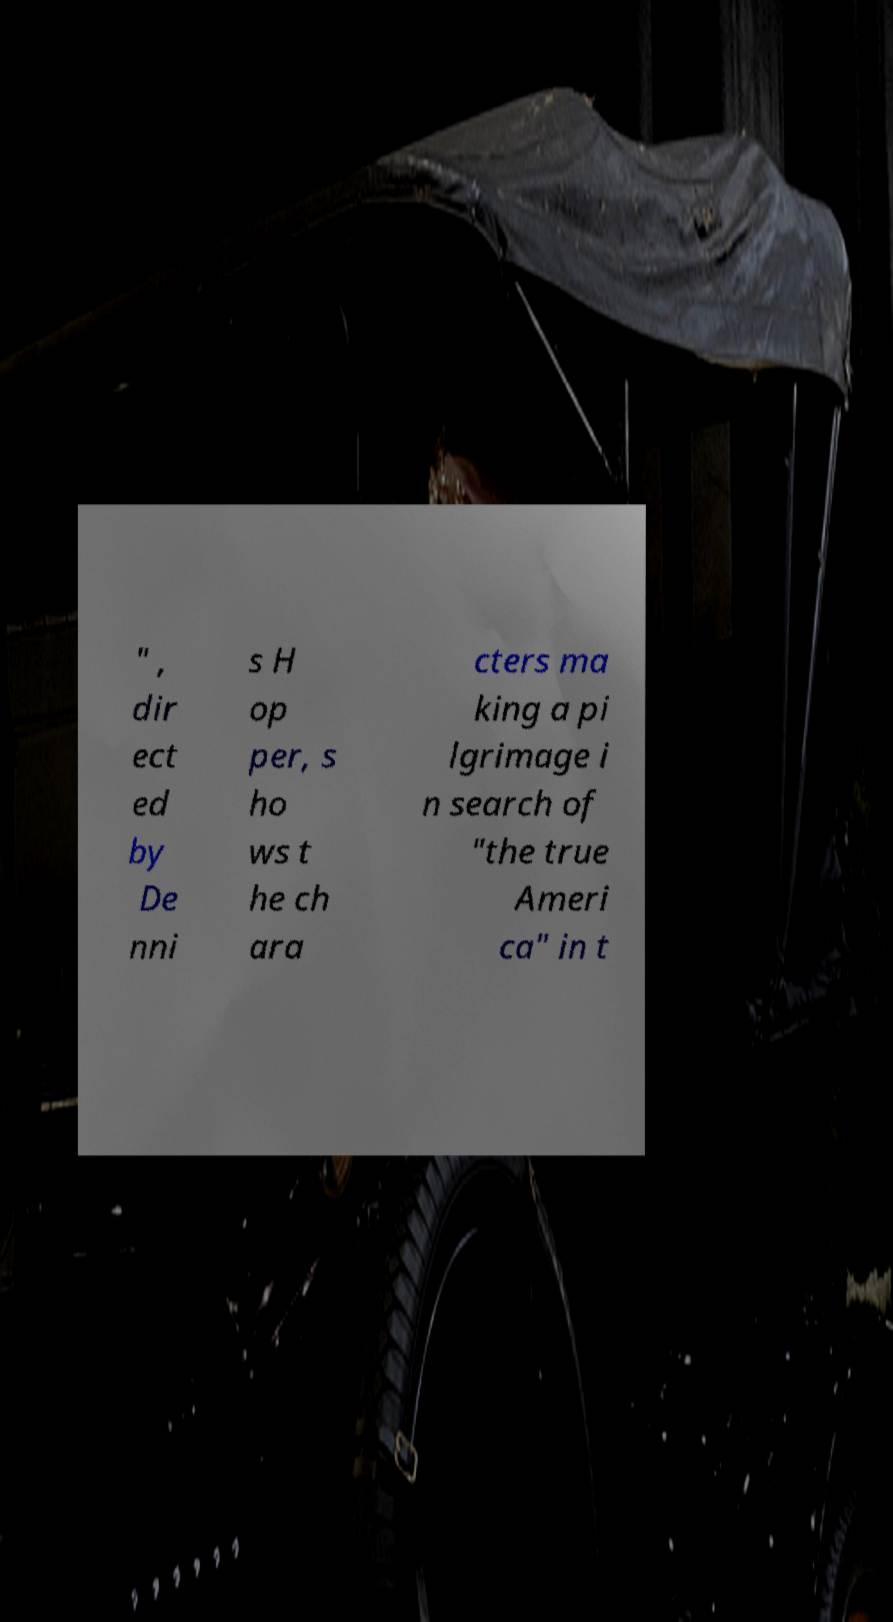Can you accurately transcribe the text from the provided image for me? " , dir ect ed by De nni s H op per, s ho ws t he ch ara cters ma king a pi lgrimage i n search of "the true Ameri ca" in t 